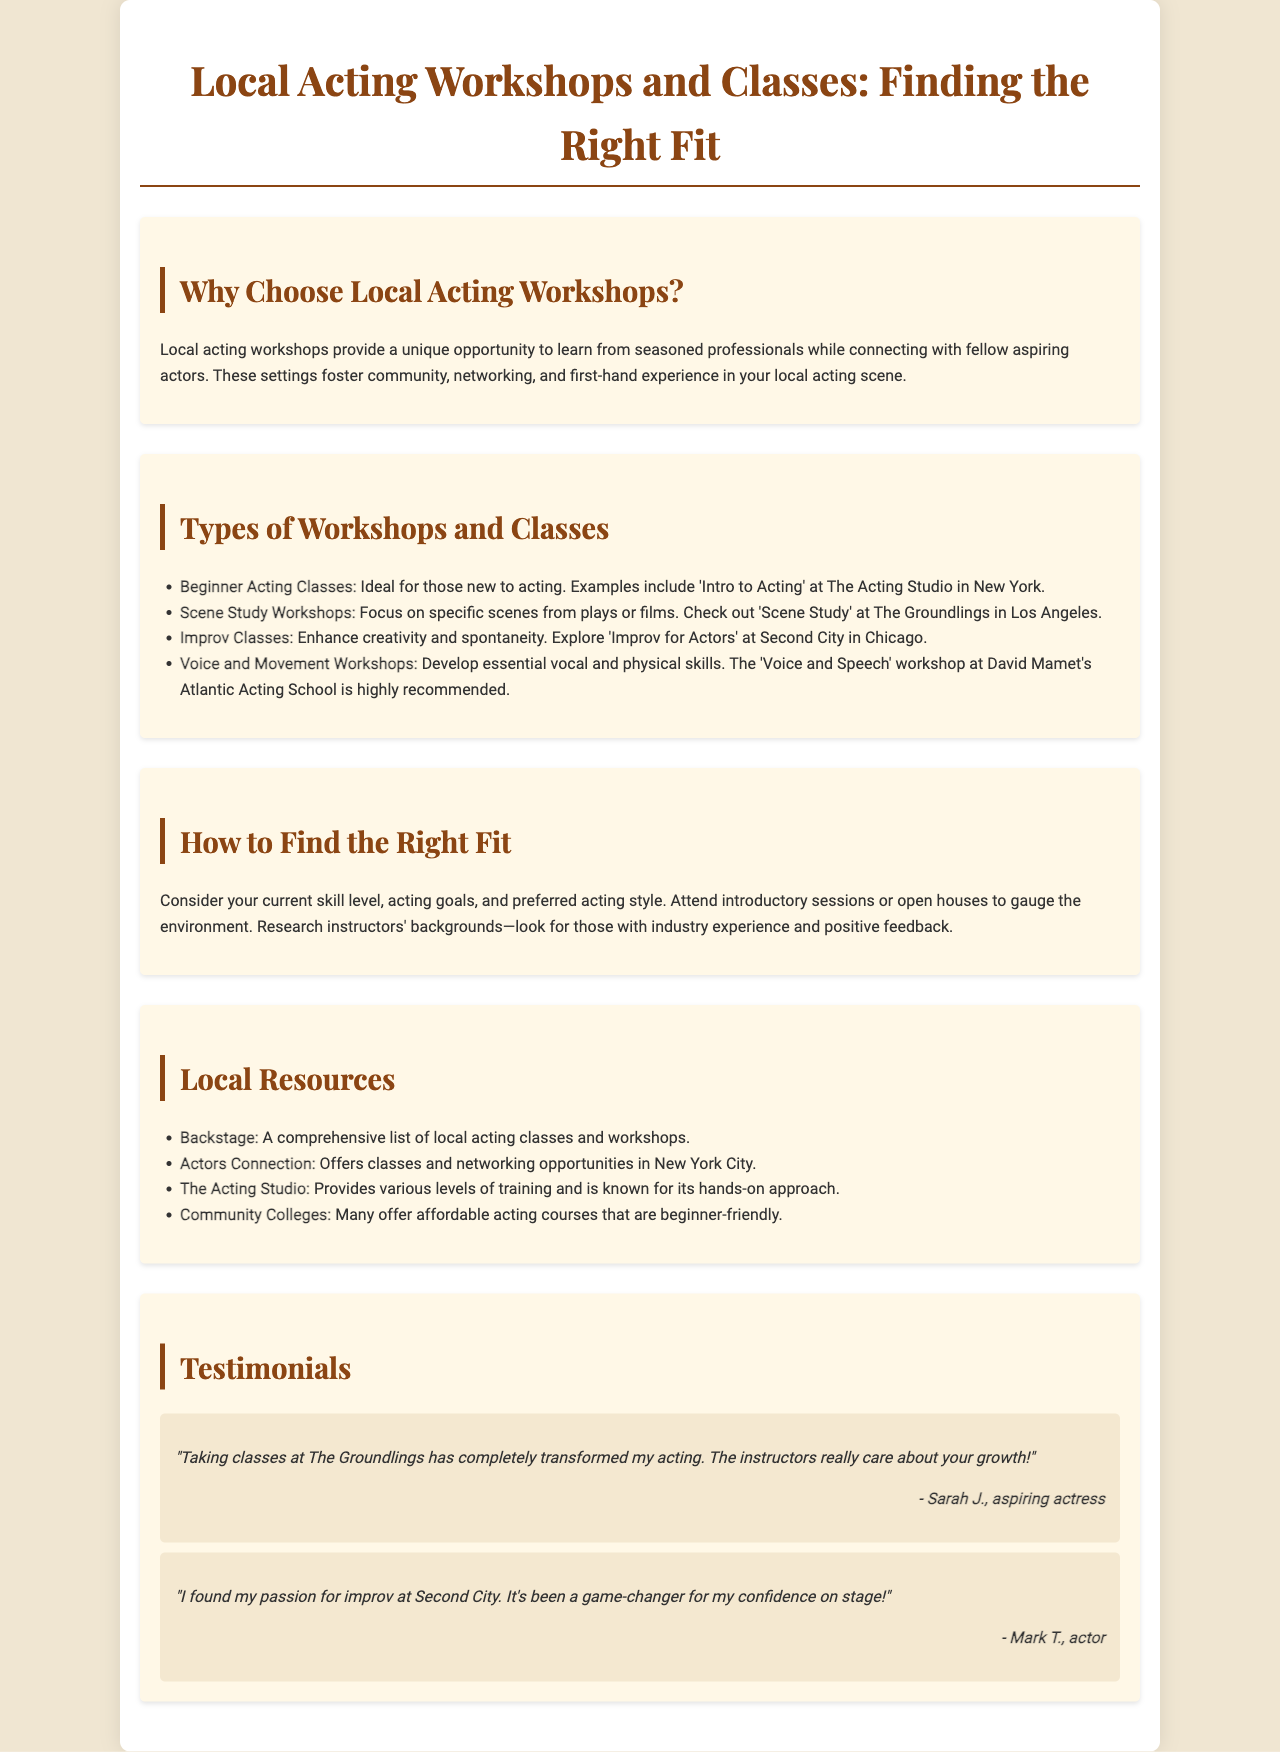What type of acting class is ideal for beginners? The brochure specifies that 'Intro to Acting' at The Acting Studio in New York is ideal for beginners.
Answer: Intro to Acting What is the focus of Scene Study Workshops? Scene Study Workshops focus on specific scenes from plays or films.
Answer: Specific scenes Name a recommended workshop for Voice and Movement. The brochure highlights the 'Voice and Speech' workshop at David Mamet's Atlantic Acting School as highly recommended.
Answer: Voice and Speech Which resource offers a comprehensive list of local acting classes? The document states that Backstage provides a comprehensive list of local acting classes and workshops.
Answer: Backstage What should you consider when finding the right fit for acting classes? The brochure suggests considering your current skill level, acting goals, and preferred acting style.
Answer: Skills and goals Which city is mentioned for networking opportunities by Actors Connection? It is mentioned that Actors Connection offers classes and networking opportunities in New York City.
Answer: New York City How did Sarah J. feel about her classes at The Groundlings? Sarah J. mentions that taking classes at The Groundlings completely transformed her acting.
Answer: Transformed What type of classes do community colleges often provide? The document notes that community colleges often provide affordable acting courses that are beginner-friendly.
Answer: Affordable beginner-friendly courses 